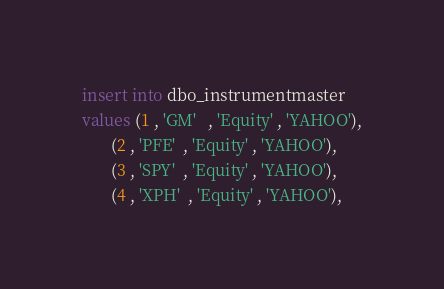<code> <loc_0><loc_0><loc_500><loc_500><_SQL_>
insert into dbo_instrumentmaster
values (1 , 'GM'   , 'Equity' , 'YAHOO'),
	   (2 , 'PFE'  , 'Equity' , 'YAHOO'),
	   (3 , 'SPY'  , 'Equity' , 'YAHOO'),
	   (4 , 'XPH'  , 'Equity' , 'YAHOO'),</code> 